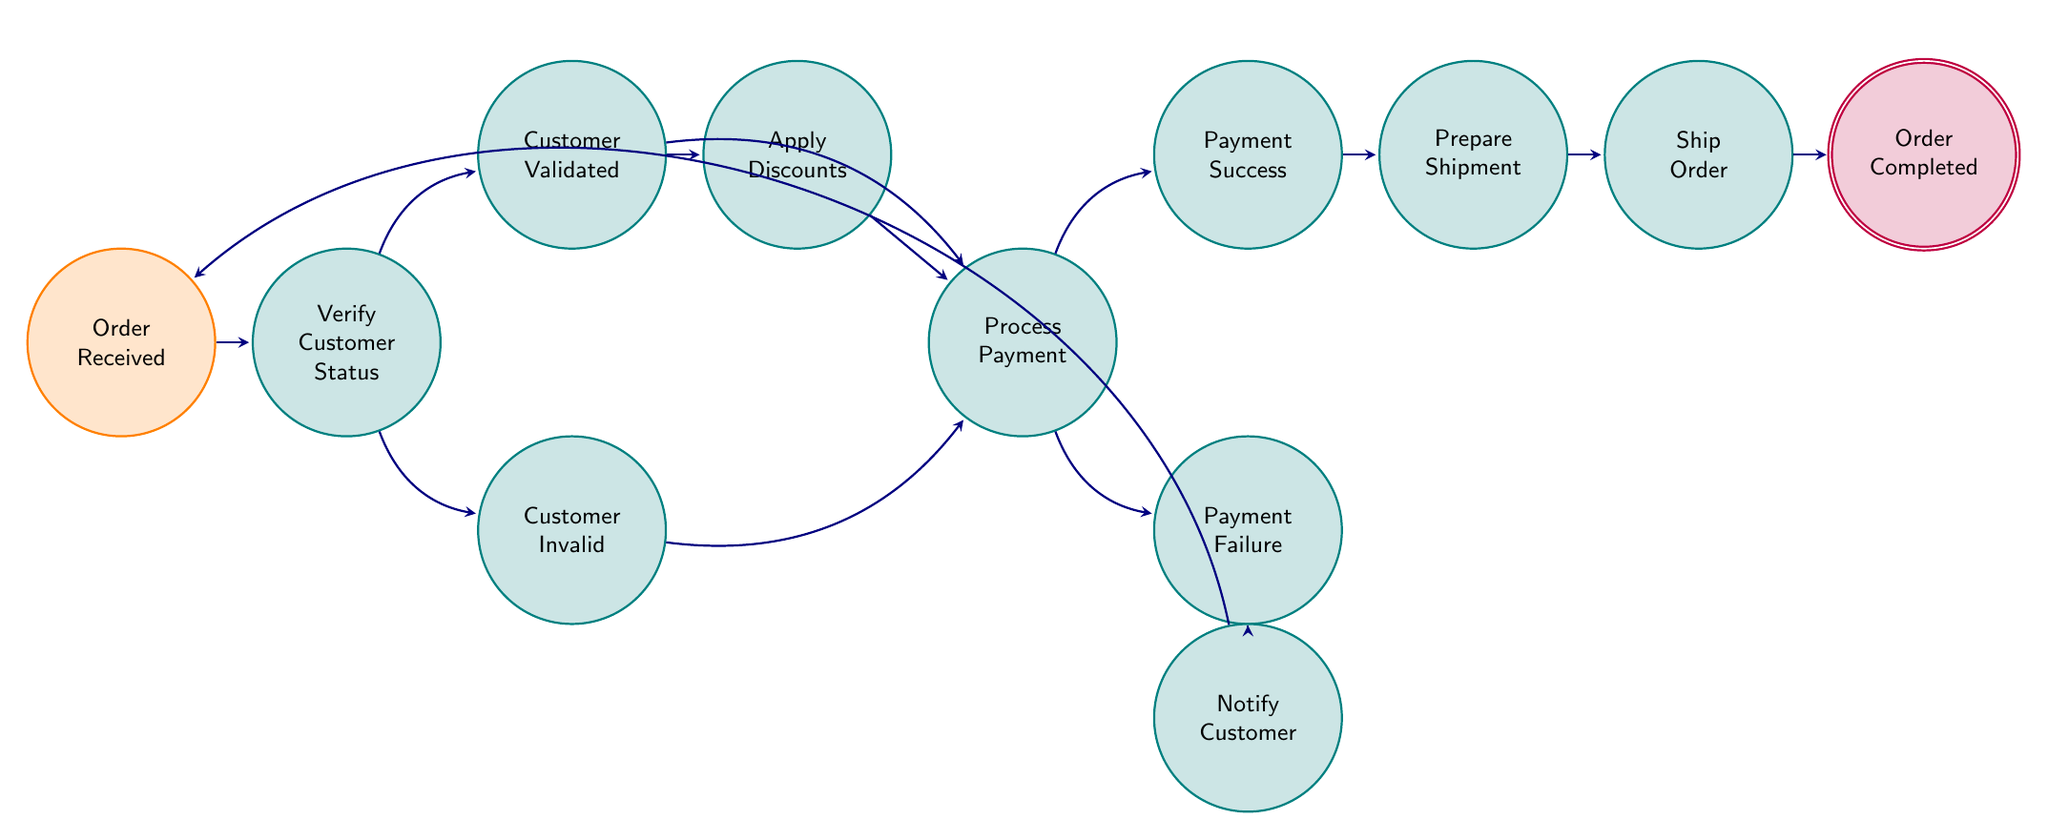What is the initial state of the process? The initial state is where the process begins, which is indicated in the diagram as "Order Received." It is marked specially to show it is the entry point into the finite state machine.
Answer: Order Received How many final states are there? The final state is defined as the endpoint of the process. In the diagram, "Order Completed" is noted as the only final state, indicating that there is one conclusion to the process.
Answer: 1 What happens when a customer is validated? If the customer is validated, the process progresses to both "Apply Discounts" and "Process Payment." The diagram shows a direct connection from "Customer Validated" to these two states, indicating that both actions can occur next.
Answer: Apply Discounts, Process Payment What state follows after a payment failure? After "Payment Failure," the process transitions to the "Notify Customer" state. This indicates an action to inform the customer about the unsuccessful payment. The arrow in the diagram clearly shows this direction.
Answer: Notify Customer What action occurs if the payment is successful? Upon successful payment, the next step in the process is to "Prepare Shipment." The diagram connects "Payment Success" to "Prepare Shipment," indicating that the next task is preparing the order for delivery.
Answer: Prepare Shipment How many total nodes are present in the diagram? The total number of nodes includes all unique states in the finite state machine, which are represented as circles in the diagram. Counting each state gives a total of 12 distinct nodes in the process flow.
Answer: 12 What does the node "Verify Customer Status" entail? "Verify Customer Status" is a crucial state where the wholesaler checks if the customer, in this case, the art studio, qualifies for any discounts or special offers. It serves as a decision point that leads to either validation or invalidation.
Answer: Check eligibility What state leads to "Ship Order"? The state that directly leads to "Ship Order" is "Prepare Shipment." This means that after the shipment of the order is set up, the next step is to dispatch the order to the customer's address, as shown in the flow.
Answer: Prepare Shipment What is indicated if the customer is invalid? If the customer is determined to be invalid, the next step in the process is still "Process Payment." This shows that, regardless of customer status, payment processing is a necessary action to complete the order cycle.
Answer: Process Payment 